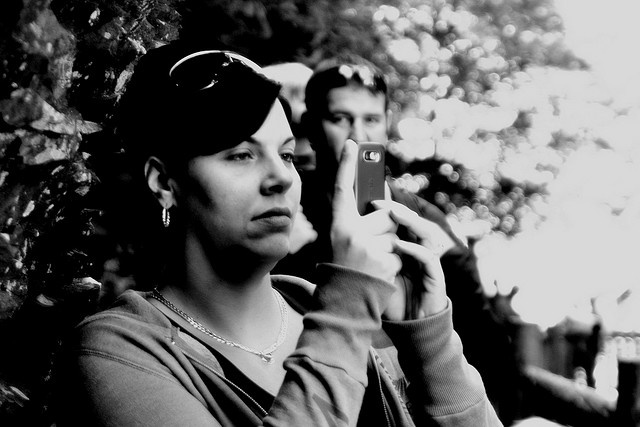Describe the objects in this image and their specific colors. I can see people in black, darkgray, gray, and lightgray tones, people in black, darkgray, lightgray, and gray tones, cell phone in black, gray, darkgray, and lightgray tones, and cell phone in black, gray, darkgray, and lightgray tones in this image. 